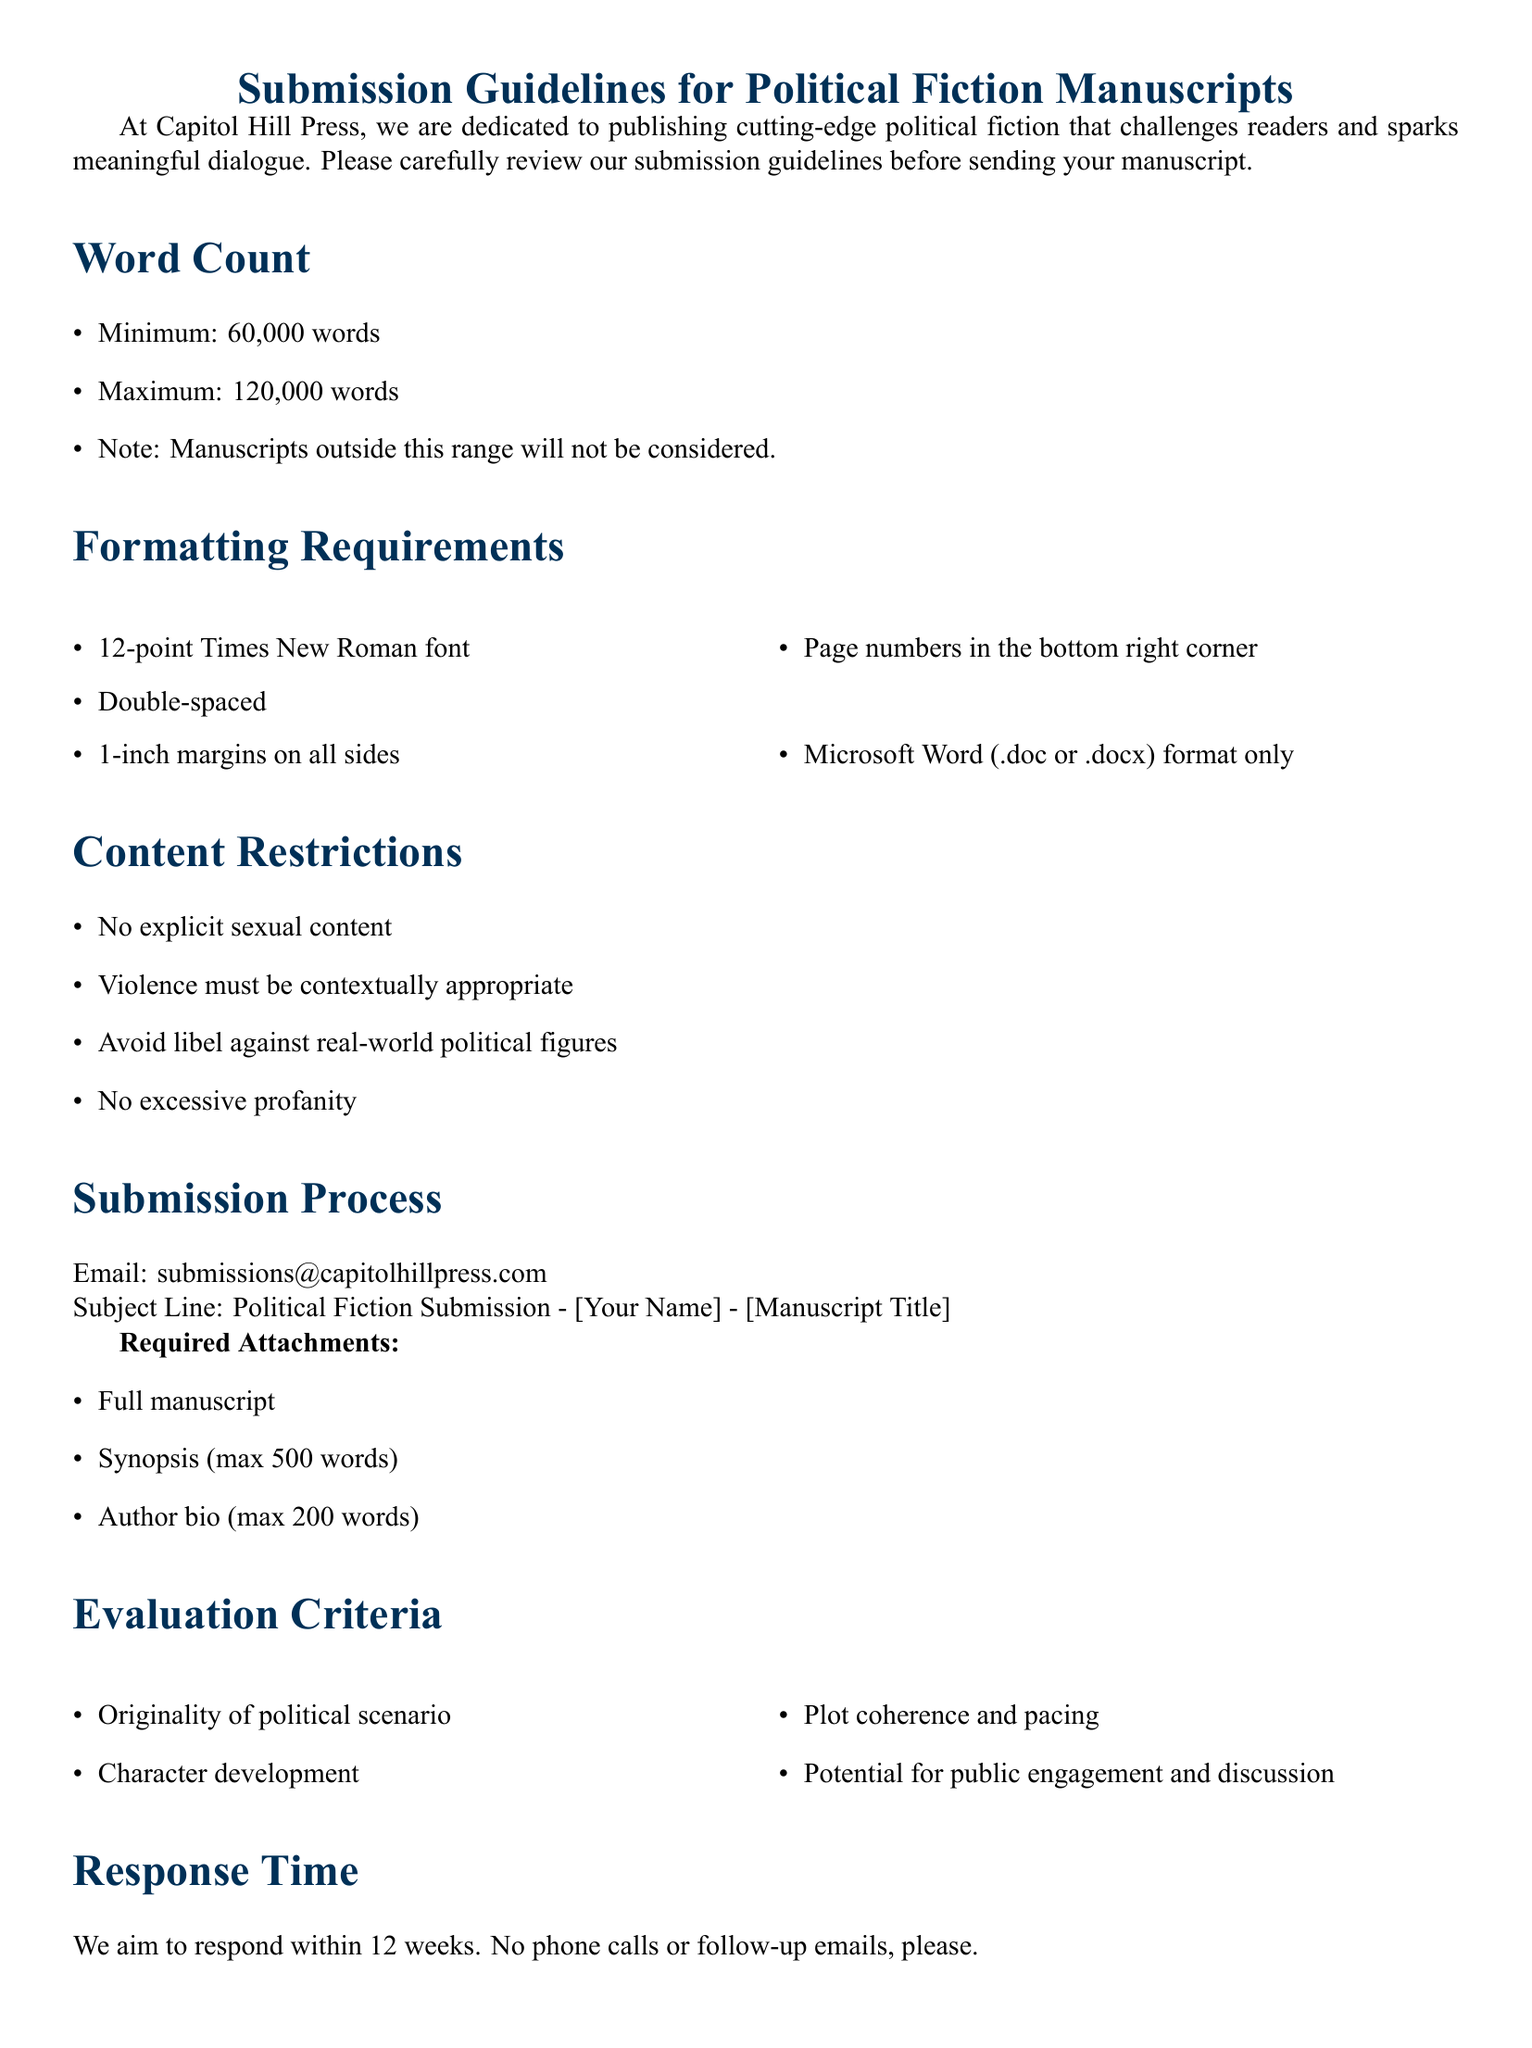What is the minimum word count for submissions? The minimum word count is specified clearly in the document, set at 60,000 words.
Answer: 60,000 words What is the maximum word count for submissions? The maximum word count is stipulated in the guidelines, which limits manuscripts to 120,000 words.
Answer: 120,000 words What font size is required for submissions? The document mentions that the manuscript must use a 12-point font size.
Answer: 12-point What document format is accepted for submissions? The submission guidelines specify that only Microsoft Word format (.doc or .docx) will be accepted.
Answer: .doc or .docx How long does the press aim to respond to submissions? The timeframe for response is indicated in the document, which states a goal of replying within 12 weeks.
Answer: 12 weeks What is the maximum length for the synopsis? The document clearly states that the synopsis should have a maximum length of 500 words.
Answer: 500 words Are submissions allowed to contain explicit sexual content? Content restrictions in the document explicitly state that no explicit sexual content is permissible in the manuscripts.
Answer: No What should be included in the subject line of the submission email? The guidelines specify that the subject line must include the sender's name and manuscript title, formatted accordingly.
Answer: Political Fiction Submission - [Your Name] - [Manuscript Title] What is one of the evaluation criteria mentioned in the document? The document outlines several evaluation criteria, including originality of the political scenario as part of the assessment.
Answer: Originality of political scenario 